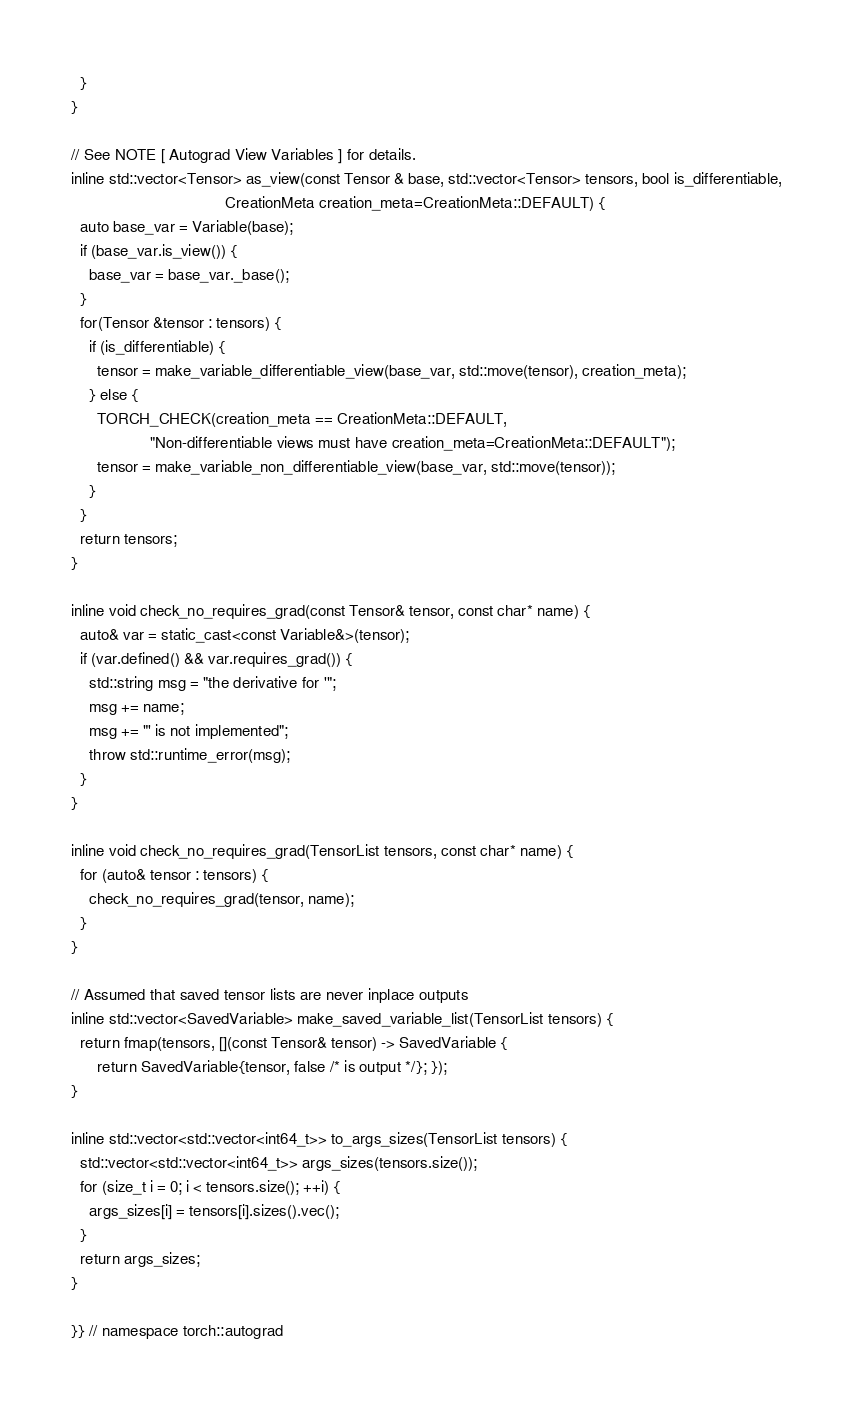<code> <loc_0><loc_0><loc_500><loc_500><_C_>  }
}

// See NOTE [ Autograd View Variables ] for details.
inline std::vector<Tensor> as_view(const Tensor & base, std::vector<Tensor> tensors, bool is_differentiable,
                                   CreationMeta creation_meta=CreationMeta::DEFAULT) {
  auto base_var = Variable(base);
  if (base_var.is_view()) {
    base_var = base_var._base();
  }
  for(Tensor &tensor : tensors) {
    if (is_differentiable) {
      tensor = make_variable_differentiable_view(base_var, std::move(tensor), creation_meta);
    } else {
      TORCH_CHECK(creation_meta == CreationMeta::DEFAULT,
                  "Non-differentiable views must have creation_meta=CreationMeta::DEFAULT");
      tensor = make_variable_non_differentiable_view(base_var, std::move(tensor));
    }
  }
  return tensors;
}

inline void check_no_requires_grad(const Tensor& tensor, const char* name) {
  auto& var = static_cast<const Variable&>(tensor);
  if (var.defined() && var.requires_grad()) {
    std::string msg = "the derivative for '";
    msg += name;
    msg += "' is not implemented";
    throw std::runtime_error(msg);
  }
}

inline void check_no_requires_grad(TensorList tensors, const char* name) {
  for (auto& tensor : tensors) {
    check_no_requires_grad(tensor, name);
  }
}

// Assumed that saved tensor lists are never inplace outputs
inline std::vector<SavedVariable> make_saved_variable_list(TensorList tensors) {
  return fmap(tensors, [](const Tensor& tensor) -> SavedVariable {
      return SavedVariable{tensor, false /* is output */}; });
}

inline std::vector<std::vector<int64_t>> to_args_sizes(TensorList tensors) {
  std::vector<std::vector<int64_t>> args_sizes(tensors.size());
  for (size_t i = 0; i < tensors.size(); ++i) {
    args_sizes[i] = tensors[i].sizes().vec();
  }
  return args_sizes;
}

}} // namespace torch::autograd
</code> 